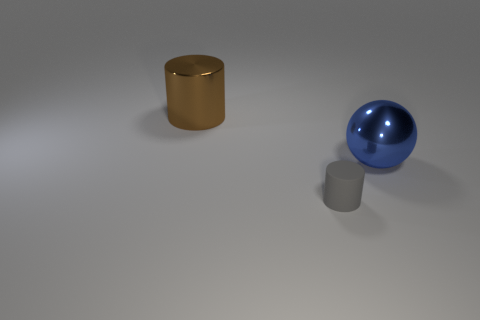Add 1 blue shiny spheres. How many objects exist? 4 Subtract all cylinders. How many objects are left? 1 Add 1 shiny cylinders. How many shiny cylinders exist? 2 Subtract 1 brown cylinders. How many objects are left? 2 Subtract all tiny brown metal objects. Subtract all brown cylinders. How many objects are left? 2 Add 1 large brown things. How many large brown things are left? 2 